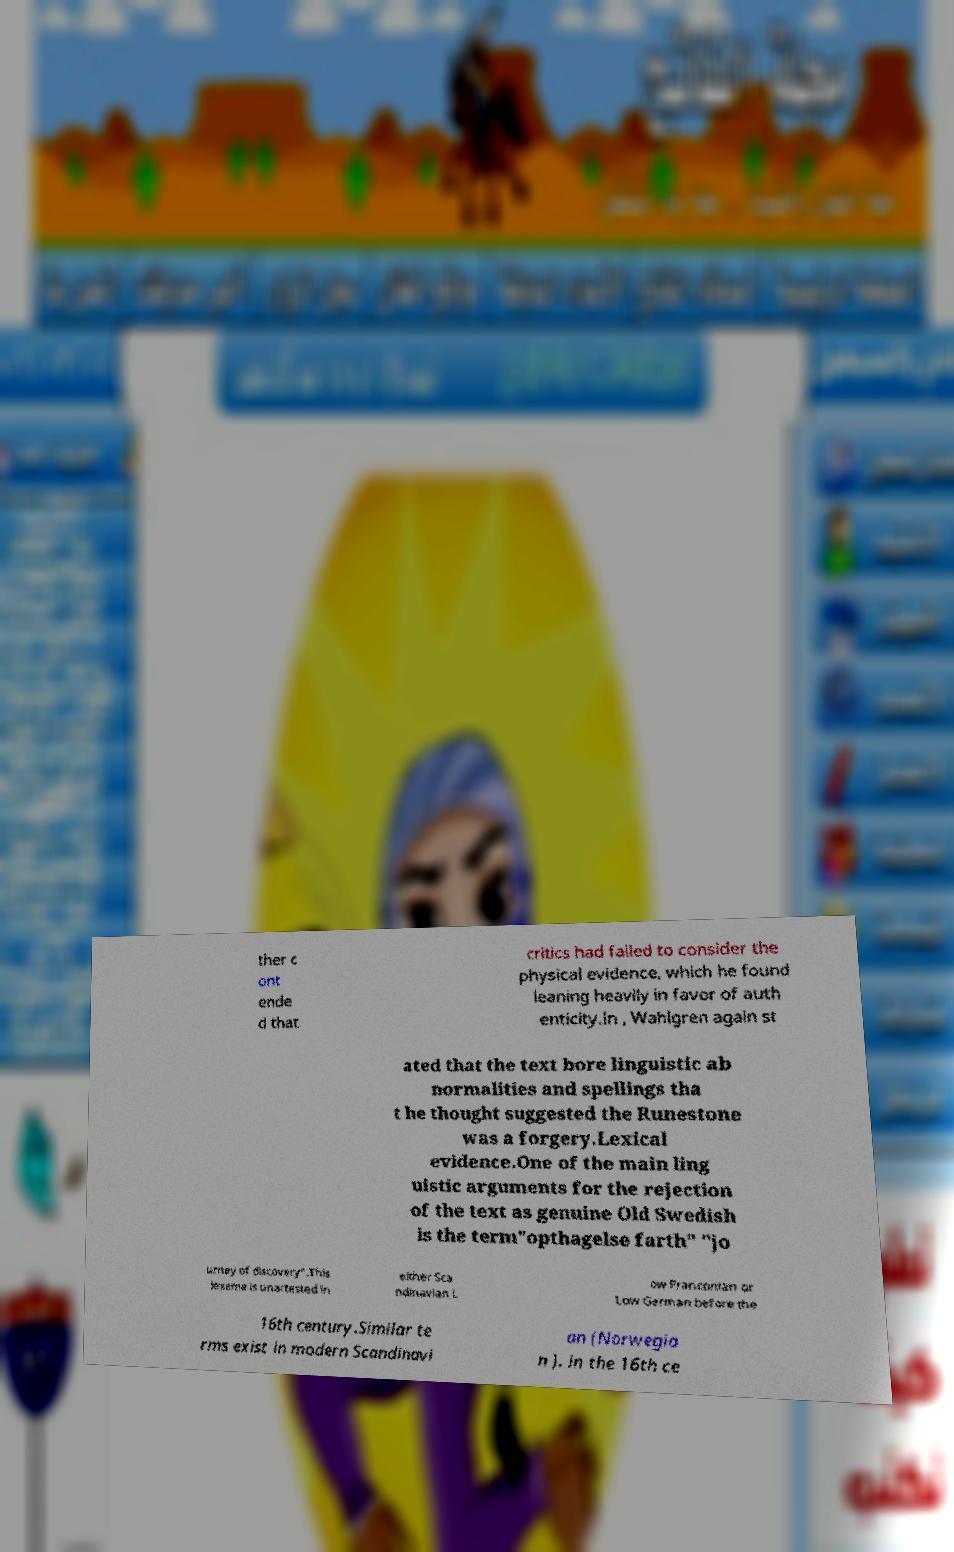For documentation purposes, I need the text within this image transcribed. Could you provide that? ther c ont ende d that critics had failed to consider the physical evidence, which he found leaning heavily in favor of auth enticity.In , Wahlgren again st ated that the text bore linguistic ab normalities and spellings tha t he thought suggested the Runestone was a forgery.Lexical evidence.One of the main ling uistic arguments for the rejection of the text as genuine Old Swedish is the term"opthagelse farth" "jo urney of discovery".This lexeme is unattested in either Sca ndinavian L ow Franconian or Low German before the 16th century.Similar te rms exist in modern Scandinavi an (Norwegia n ). in the 16th ce 